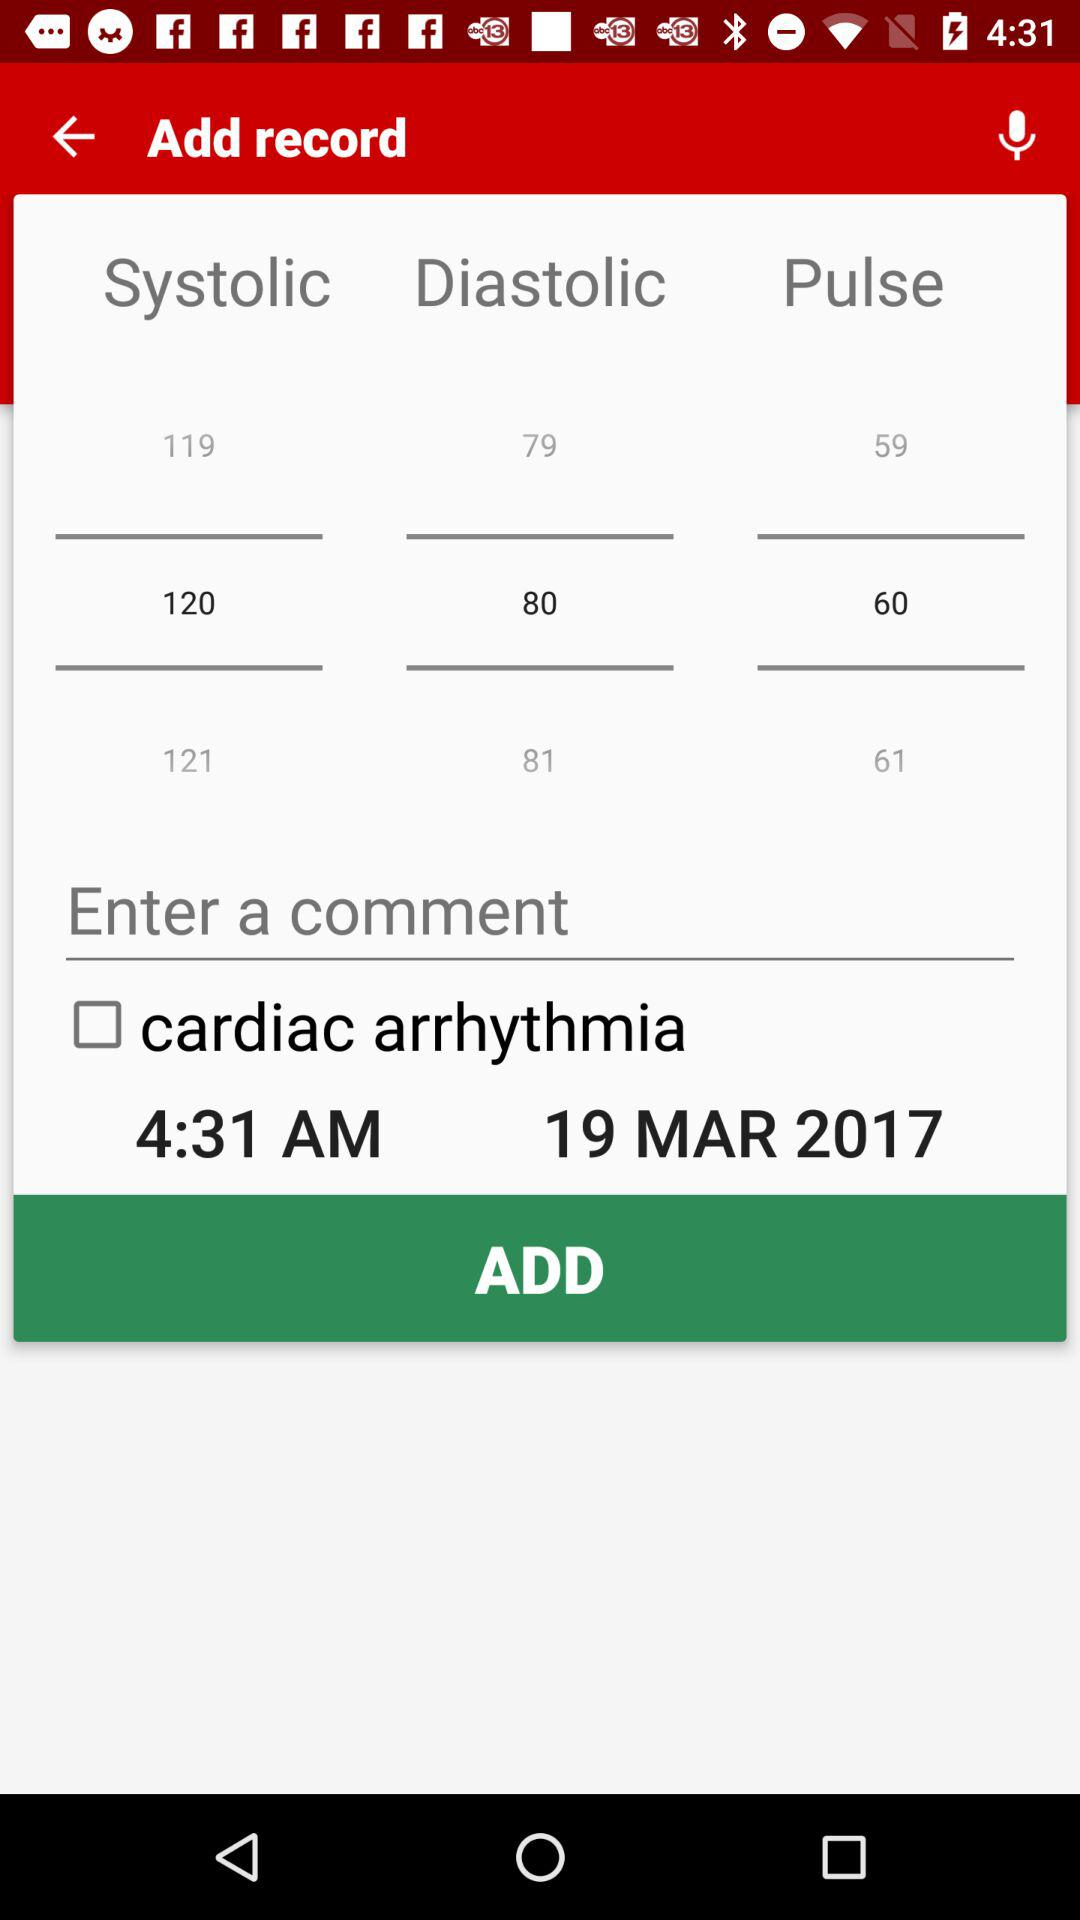What is the systolic blood pressure? The systolic blood pressure is 120. 